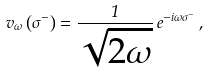<formula> <loc_0><loc_0><loc_500><loc_500>v _ { \omega } \left ( \sigma ^ { - } \right ) = { \frac { 1 } { \sqrt { 2 \omega } } } \, e ^ { - i \omega \sigma ^ { - } } \, ,</formula> 